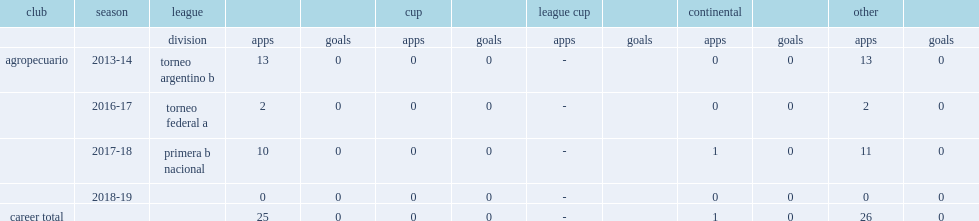Help me parse the entirety of this table. {'header': ['club', 'season', 'league', '', '', 'cup', '', 'league cup', '', 'continental', '', 'other', ''], 'rows': [['', '', 'division', 'apps', 'goals', 'apps', 'goals', 'apps', 'goals', 'apps', 'goals', 'apps', 'goals'], ['agropecuario', '2013-14', 'torneo argentino b', '13', '0', '0', '0', '-', '', '0', '0', '13', '0'], ['', '2016-17', 'torneo federal a', '2', '0', '0', '0', '-', '', '0', '0', '2', '0'], ['', '2017-18', 'primera b nacional', '10', '0', '0', '0', '-', '', '1', '0', '11', '0'], ['', '2018-19', '', '0', '0', '0', '0', '-', '', '0', '0', '0', '0'], ['career total', '', '', '25', '0', '0', '0', '-', '', '1', '0', '26', '0']]} Which club did maldonado join of torneo federal a in 2016-17? Agropecuario. 